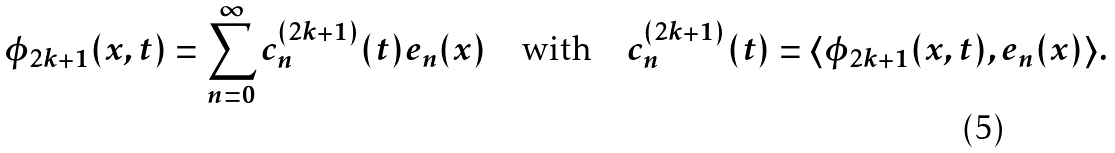Convert formula to latex. <formula><loc_0><loc_0><loc_500><loc_500>\phi _ { 2 k + 1 } ( x , t ) = \sum _ { n = 0 } ^ { \infty } c ^ { ( 2 k + 1 ) } _ { n } ( t ) e _ { n } ( x ) \quad \text {with} \quad c ^ { ( 2 k + 1 ) } _ { n } ( t ) = \langle \phi _ { 2 k + 1 } ( x , t ) , e _ { n } ( x ) \rangle .</formula> 